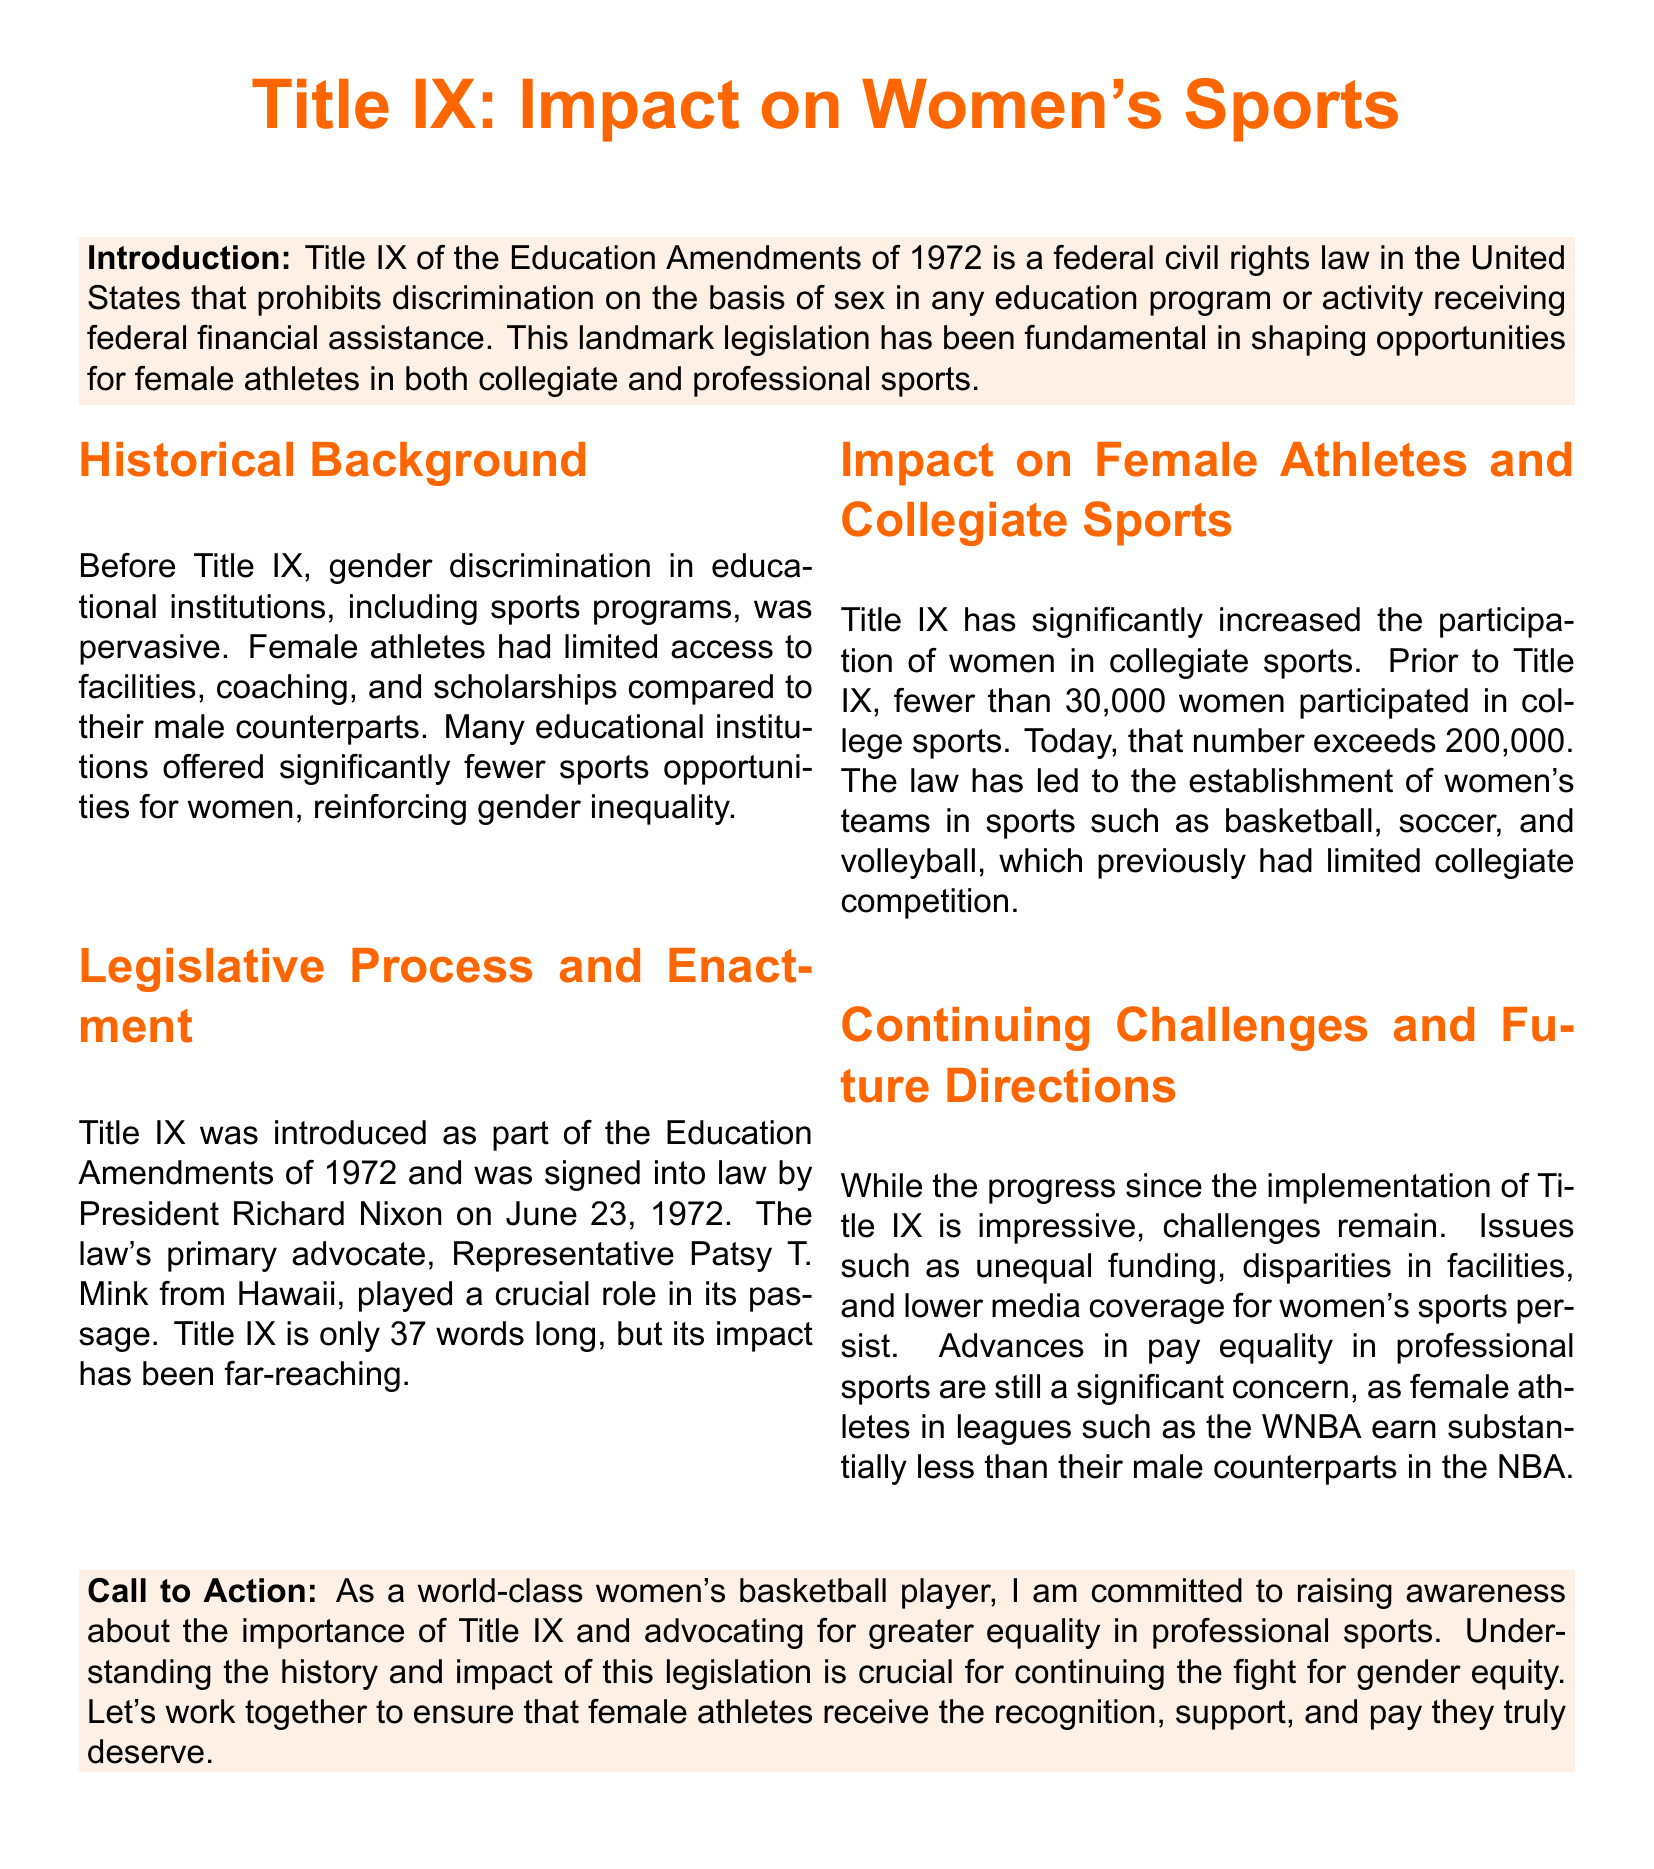what is Title IX? Title IX is a federal civil rights law that prohibits discrimination on the basis of sex in any education program or activity receiving federal financial assistance.
Answer: federal civil rights law when was Title IX signed into law? Title IX was signed into law on June 23, 1972.
Answer: June 23, 1972 who was the primary advocate for Title IX? The primary advocate for Title IX was Representative Patsy T. Mink from Hawaii.
Answer: Patsy T. Mink how many women participated in college sports prior to Title IX? Fewer than 30,000 women participated in college sports before Title IX.
Answer: fewer than 30,000 how many women participate in college sports today? Today, more than 200,000 women participate in college sports.
Answer: exceeds 200,000 what are some challenges mentioned regarding women’s sports? Challenges include unequal funding, disparities in facilities, and lower media coverage for women's sports.
Answer: unequal funding, disparities in facilities, lower media coverage what is the main concern for female athletes in professional sports? The main concern is pay equality, as female athletes earn substantially less than their male counterparts.
Answer: pay equality what is the call to action for female athletes? The call to action is to raise awareness about the importance of Title IX and advocate for greater equality in professional sports.
Answer: raise awareness, advocate for equality what sports did Title IX help establish women's teams in? Title IX helped establish women's teams in sports such as basketball, soccer, and volleyball.
Answer: basketball, soccer, volleyball 